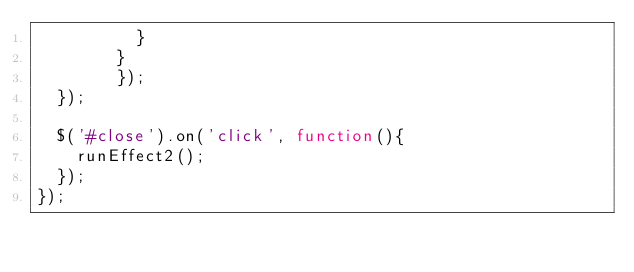Convert code to text. <code><loc_0><loc_0><loc_500><loc_500><_JavaScript_>				 	}
				}
		    });
	});	

	$('#close').on('click', function(){
		runEffect2();
	});    	
});</code> 